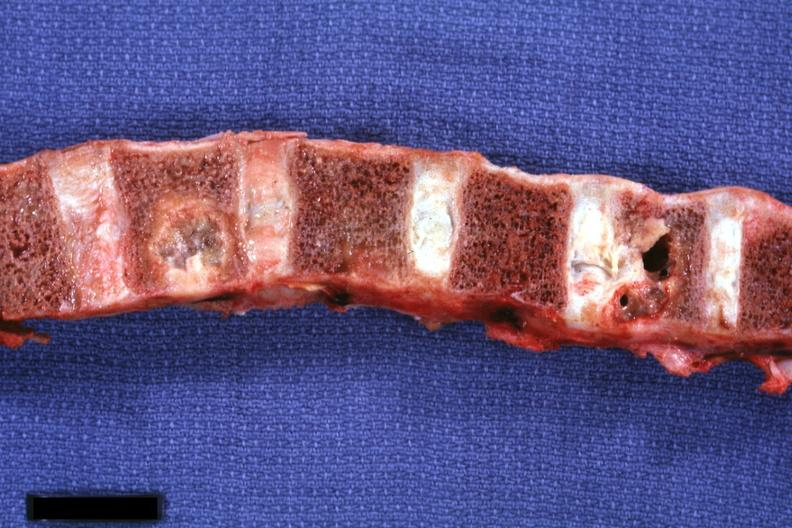how is vertebral bodies showing very nicely osteolytic metastatic lesions primary cell carcinoma penis?
Answer the question using a single word or phrase. Squamous 